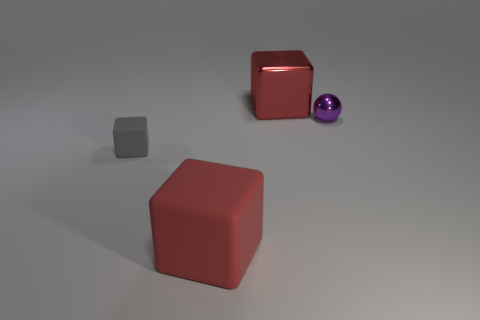What material is the large red cube left of the red object that is behind the large thing on the left side of the big metallic object? The large red cube in question, positioned to the left of the red object and behind the main subject to the left side of the conspicuous metallic object, appears to be made of a matt plastic. This inference is made considering its light reflection and texture, which differ from surfaces that typically characterize materials such as rubber, metal, or glass. 